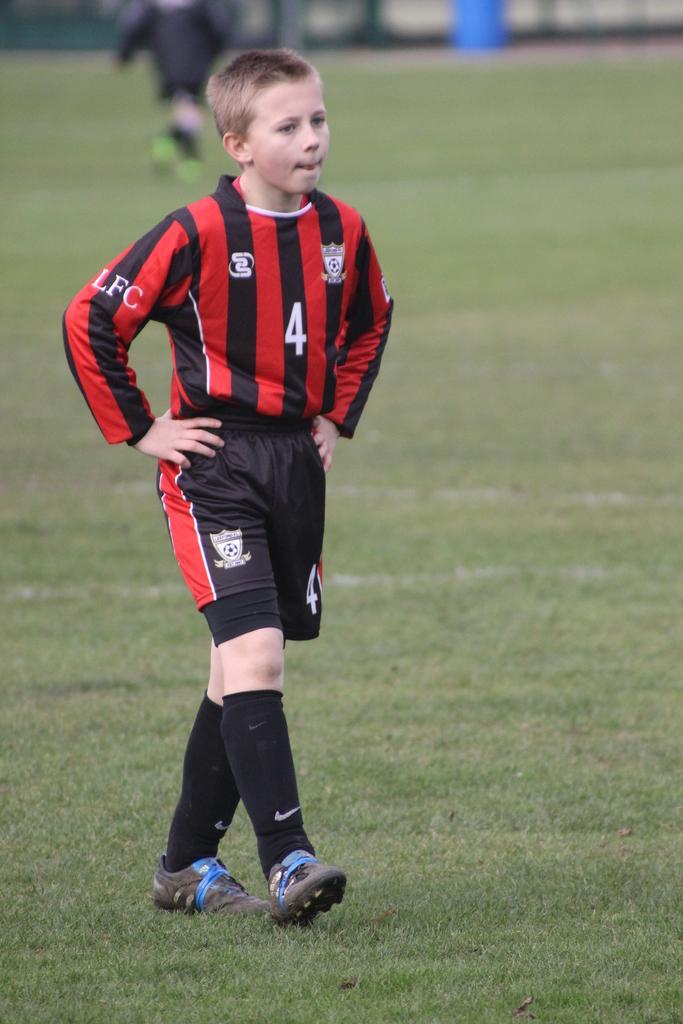How would you summarize this image in a sentence or two? In the middle of the image a person is walking. Behind him a person is standing. At the bottom of the image there is grass. Background of the image is blur. 